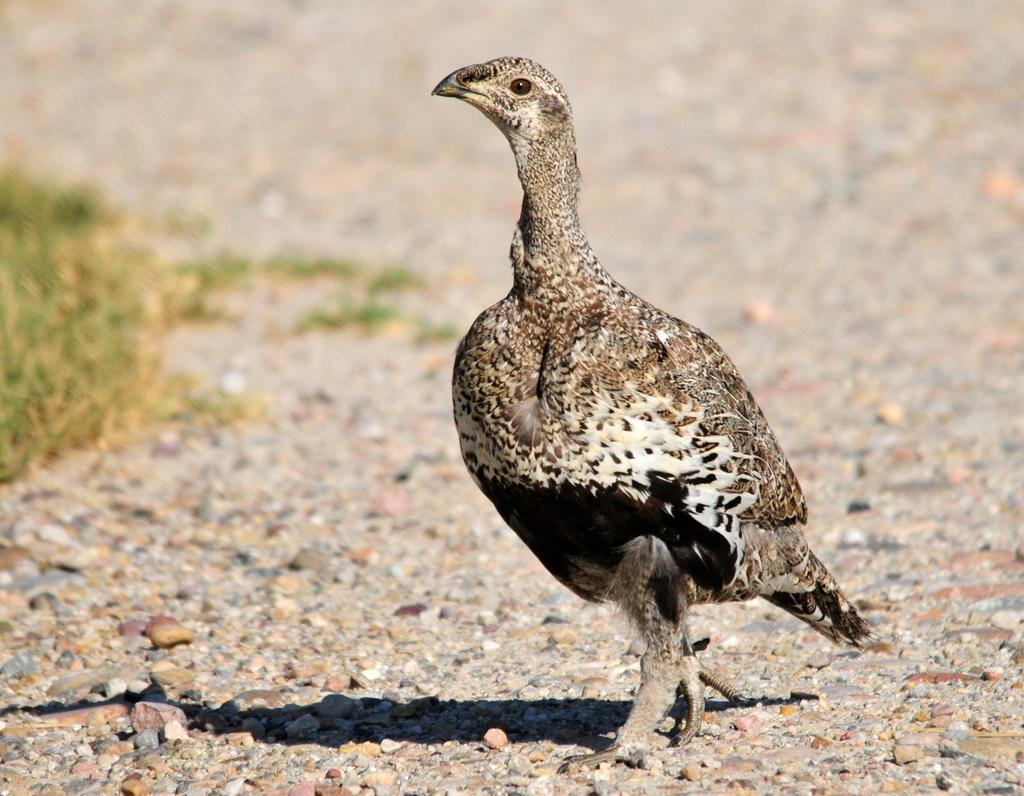How would you summarize this image in a sentence or two? In this image I can see a brown and white colour bird is standing on the ground. I can also see a shadow and number of stones on the ground. On the left side of this image I can see grass and I can also see this image is little bit blurry in the background. 